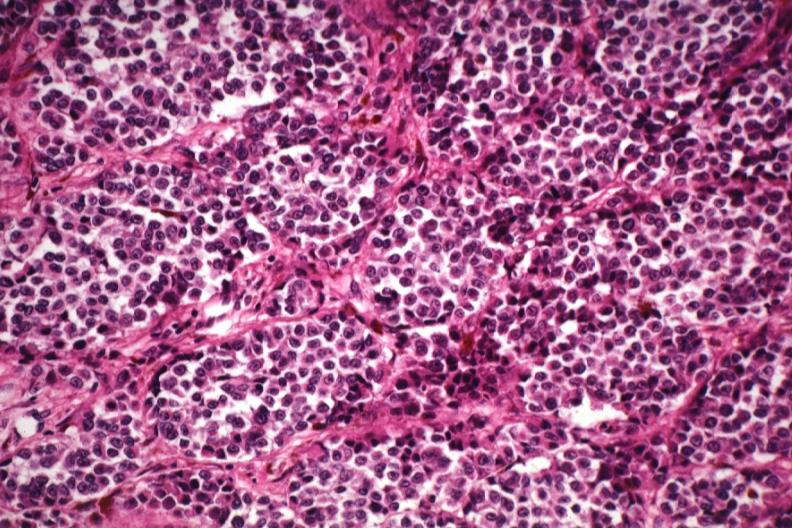how does this image show good tumor cells?
Answer the question using a single word or phrase. With little pigment except in melanophores 